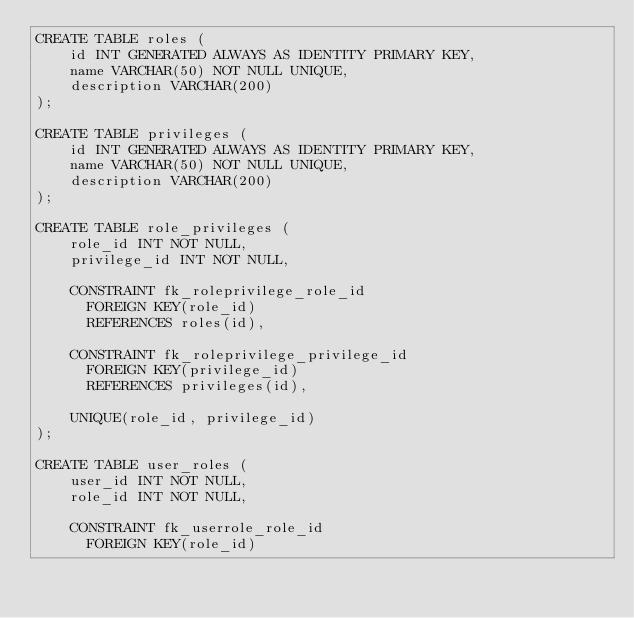Convert code to text. <code><loc_0><loc_0><loc_500><loc_500><_SQL_>CREATE TABLE roles (
	id INT GENERATED ALWAYS AS IDENTITY PRIMARY KEY,
	name VARCHAR(50) NOT NULL UNIQUE,
	description VARCHAR(200)
);

CREATE TABLE privileges (
	id INT GENERATED ALWAYS AS IDENTITY PRIMARY KEY,
	name VARCHAR(50) NOT NULL UNIQUE,
	description VARCHAR(200)
);

CREATE TABLE role_privileges (
	role_id INT NOT NULL,
	privilege_id INT NOT NULL,
	
	CONSTRAINT fk_roleprivilege_role_id
      FOREIGN KEY(role_id) 
	  REFERENCES roles(id),
	  
	CONSTRAINT fk_roleprivilege_privilege_id
      FOREIGN KEY(privilege_id) 
	  REFERENCES privileges(id),
	  
	UNIQUE(role_id, privilege_id)
);

CREATE TABLE user_roles (
	user_id INT NOT NULL,
	role_id INT NOT NULL,
	
	CONSTRAINT fk_userrole_role_id
      FOREIGN KEY(role_id) </code> 